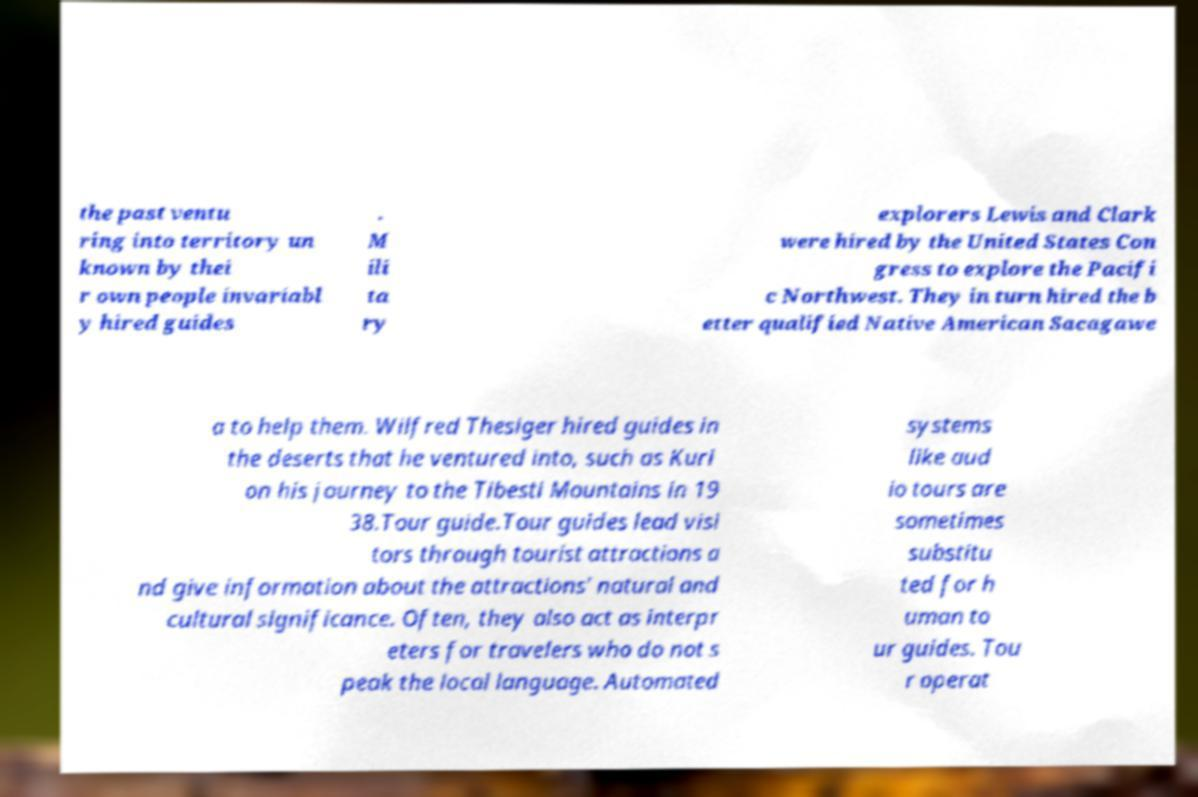There's text embedded in this image that I need extracted. Can you transcribe it verbatim? the past ventu ring into territory un known by thei r own people invariabl y hired guides . M ili ta ry explorers Lewis and Clark were hired by the United States Con gress to explore the Pacifi c Northwest. They in turn hired the b etter qualified Native American Sacagawe a to help them. Wilfred Thesiger hired guides in the deserts that he ventured into, such as Kuri on his journey to the Tibesti Mountains in 19 38.Tour guide.Tour guides lead visi tors through tourist attractions a nd give information about the attractions' natural and cultural significance. Often, they also act as interpr eters for travelers who do not s peak the local language. Automated systems like aud io tours are sometimes substitu ted for h uman to ur guides. Tou r operat 